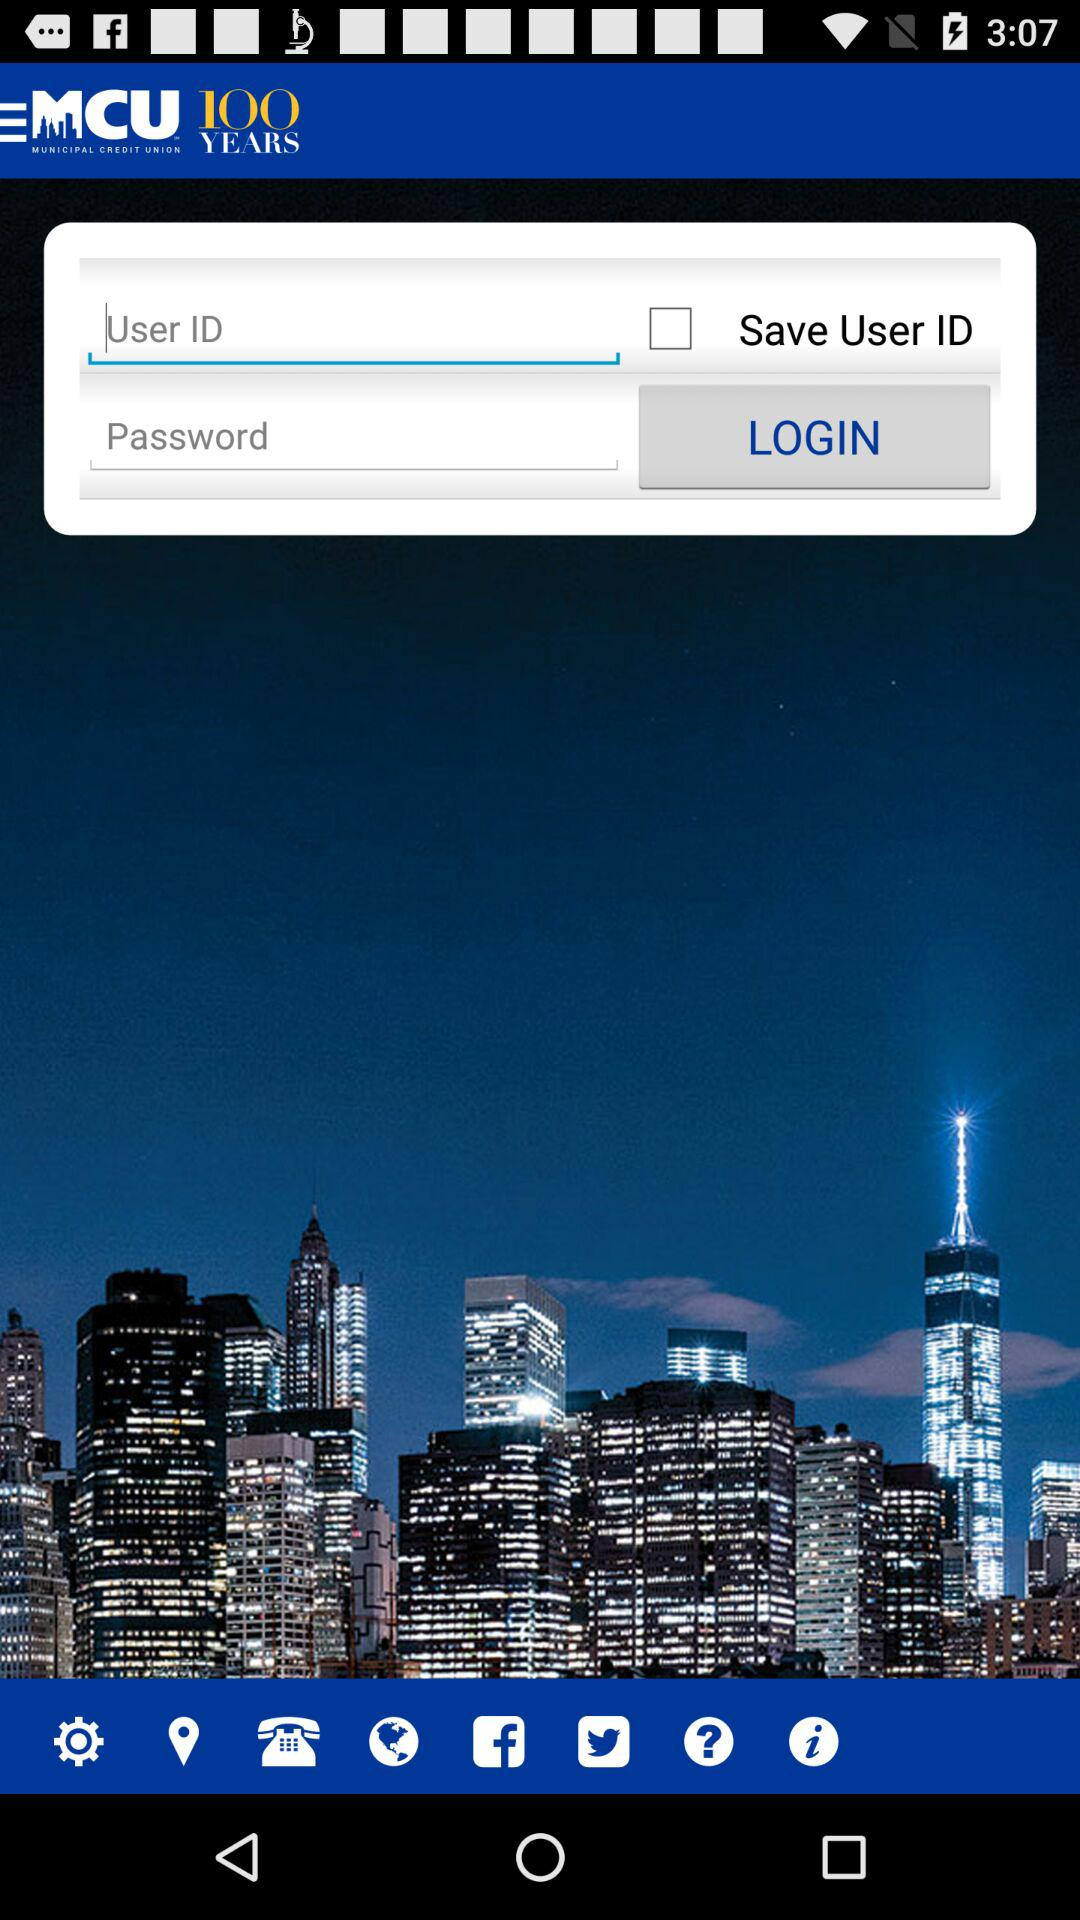What is the application name? The application name is "MCU MUNICIPAL CREDIT UNION". 